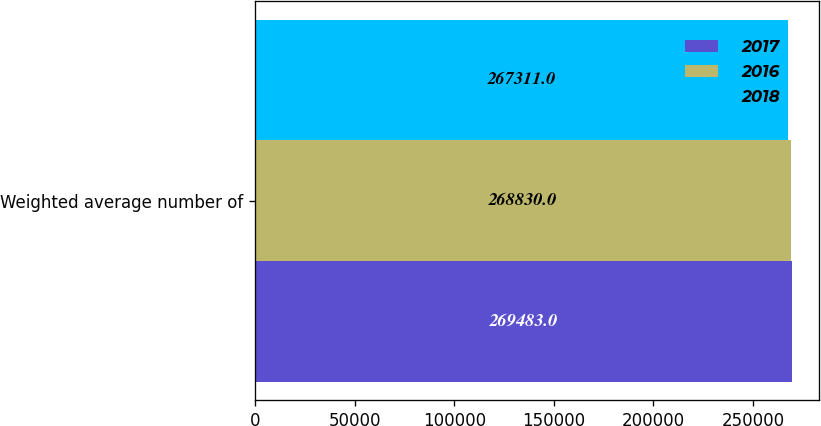Convert chart. <chart><loc_0><loc_0><loc_500><loc_500><stacked_bar_chart><ecel><fcel>Weighted average number of<nl><fcel>2017<fcel>269483<nl><fcel>2016<fcel>268830<nl><fcel>2018<fcel>267311<nl></chart> 